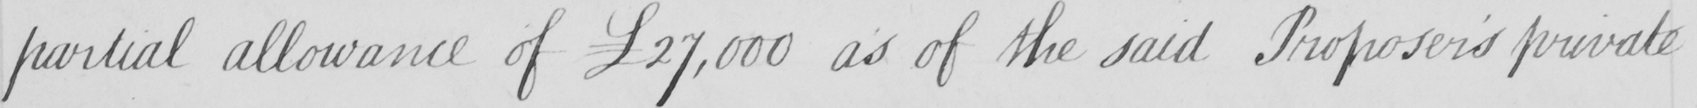What text is written in this handwritten line? partial allowance of  £27,000 as of the said Proposer ' s private 